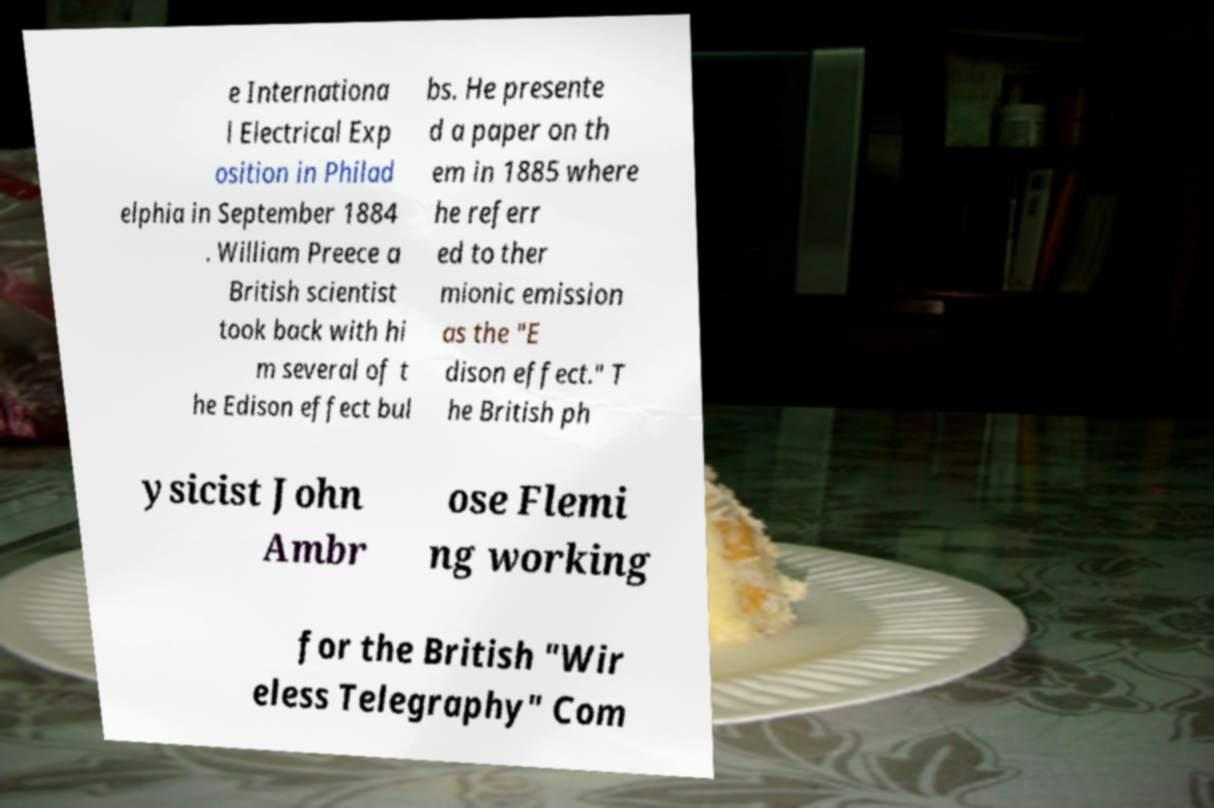Please read and relay the text visible in this image. What does it say? e Internationa l Electrical Exp osition in Philad elphia in September 1884 . William Preece a British scientist took back with hi m several of t he Edison effect bul bs. He presente d a paper on th em in 1885 where he referr ed to ther mionic emission as the "E dison effect." T he British ph ysicist John Ambr ose Flemi ng working for the British "Wir eless Telegraphy" Com 